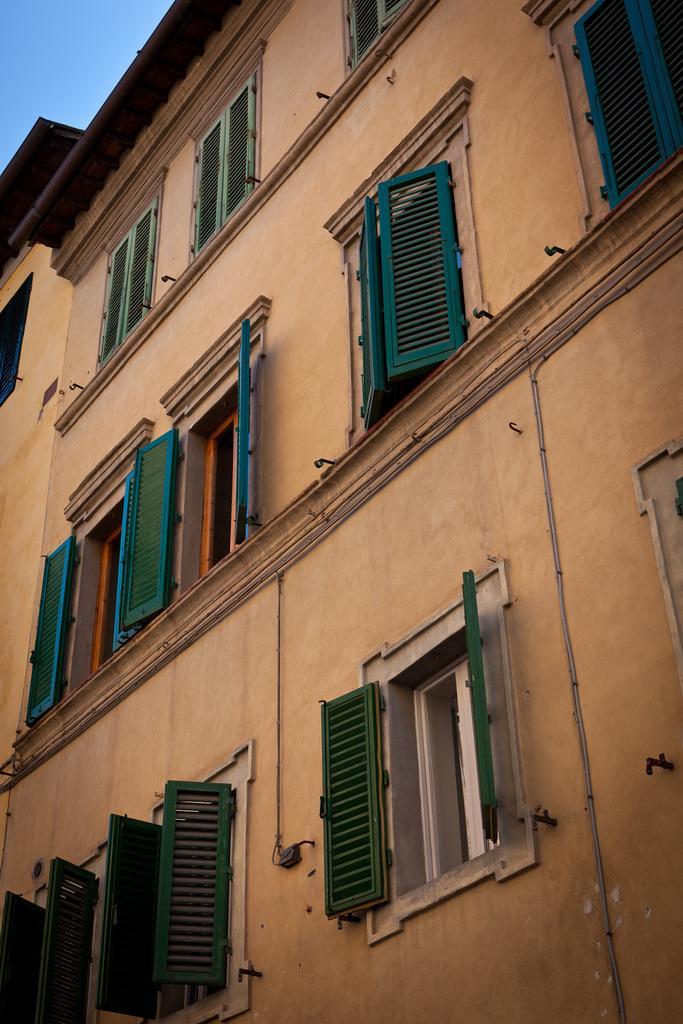Can you describe this image briefly? In this picture there is a building, to the building there are windows. At the top it is sky. 